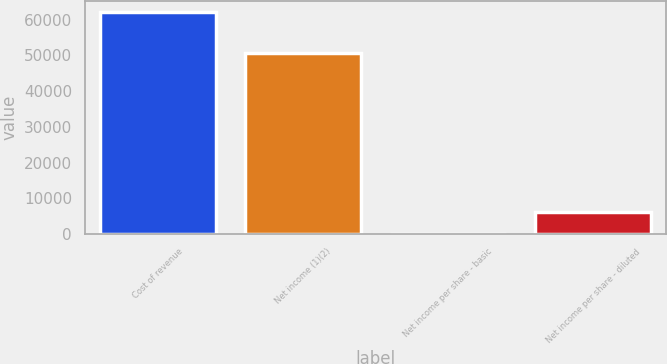Convert chart. <chart><loc_0><loc_0><loc_500><loc_500><bar_chart><fcel>Cost of revenue<fcel>Net income (1)(2)<fcel>Net income per share - basic<fcel>Net income per share - diluted<nl><fcel>62054<fcel>50562<fcel>0.17<fcel>6205.55<nl></chart> 